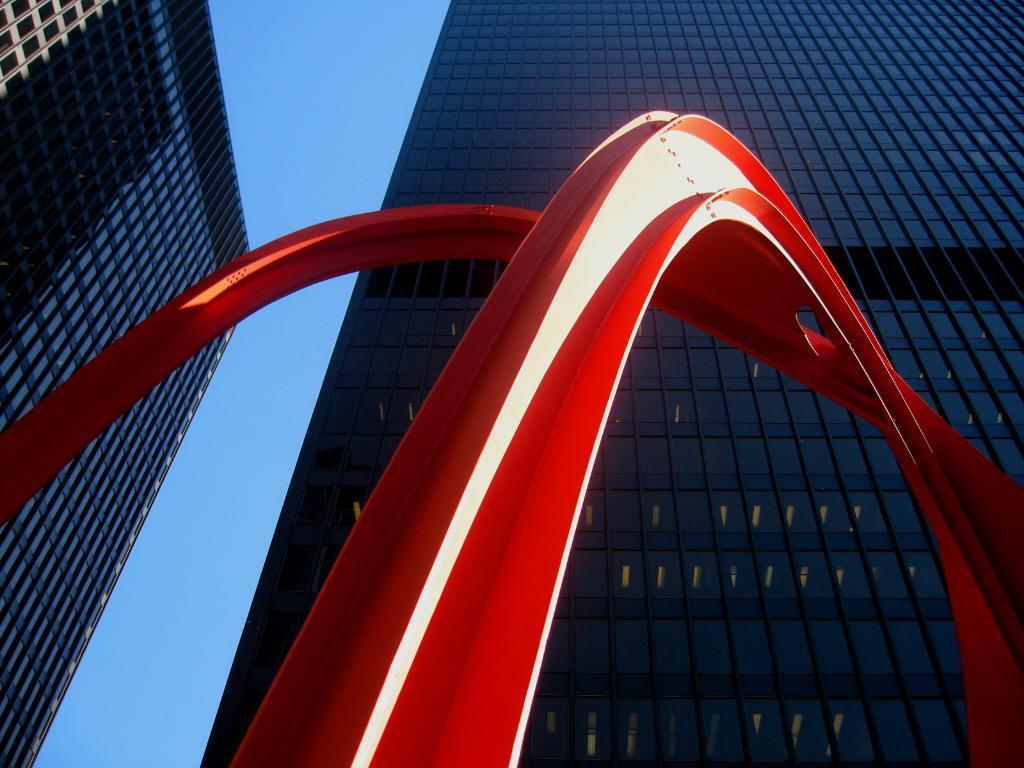In one or two sentences, can you explain what this image depicts? In the center of the image there is a sculpture. In the background we can see buildings and sky. 